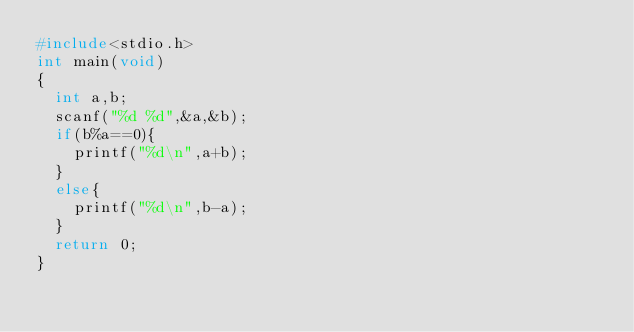<code> <loc_0><loc_0><loc_500><loc_500><_C_>#include<stdio.h>
int main(void)
{
	int a,b;
	scanf("%d %d",&a,&b);
	if(b%a==0){
		printf("%d\n",a+b);
	}
	else{
		printf("%d\n",b-a);
	}
	return 0;
}</code> 